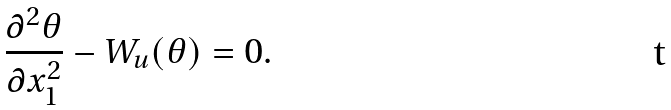<formula> <loc_0><loc_0><loc_500><loc_500>\frac { \partial ^ { 2 } \theta } { \partial x ^ { 2 } _ { 1 } } - W _ { u } ( \theta ) = 0 .</formula> 